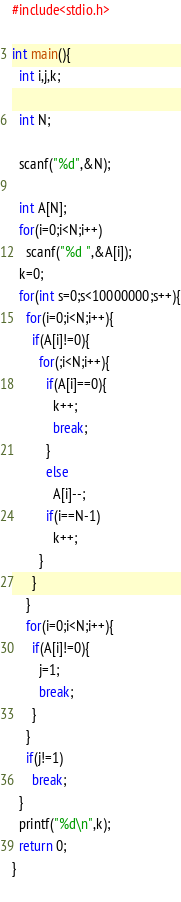<code> <loc_0><loc_0><loc_500><loc_500><_C_>#include<stdio.h>

int main(){
  int i,j,k;
  
  int N;
  
  scanf("%d",&N);
  
  int A[N];
  for(i=0;i<N;i++)
    scanf("%d ",&A[i]);
  k=0;
  for(int s=0;s<10000000;s++){
    for(i=0;i<N;i++){
      if(A[i]!=0){
        for(;i<N;i++){
          if(A[i]==0){
            k++;
            break;
          }
          else
            A[i]--;
          if(i==N-1)
            k++;
        }
      }
    }
    for(i=0;i<N;i++){
      if(A[i]!=0){
        j=1;
        break;
      }
    }
    if(j!=1)
      break;
  }
  printf("%d\n",k);
  return 0;
}
          

</code> 